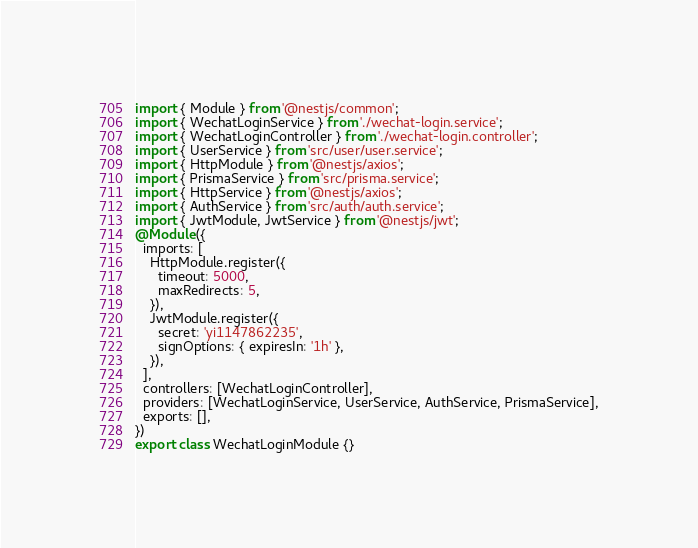Convert code to text. <code><loc_0><loc_0><loc_500><loc_500><_TypeScript_>import { Module } from '@nestjs/common';
import { WechatLoginService } from './wechat-login.service';
import { WechatLoginController } from './wechat-login.controller';
import { UserService } from 'src/user/user.service';
import { HttpModule } from '@nestjs/axios';
import { PrismaService } from 'src/prisma.service';
import { HttpService } from '@nestjs/axios';
import { AuthService } from 'src/auth/auth.service';
import { JwtModule, JwtService } from '@nestjs/jwt';
@Module({
  imports: [
    HttpModule.register({
      timeout: 5000,
      maxRedirects: 5,
    }),
    JwtModule.register({
      secret: 'yi1147862235',
      signOptions: { expiresIn: '1h' },
    }),
  ],
  controllers: [WechatLoginController],
  providers: [WechatLoginService, UserService, AuthService, PrismaService],
  exports: [],
})
export class WechatLoginModule {}
</code> 